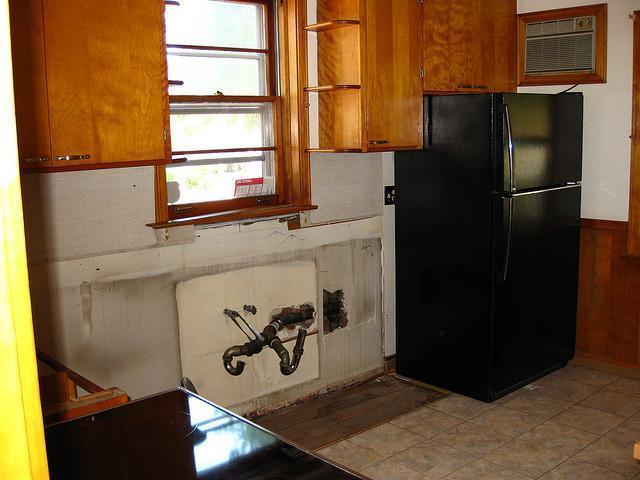How many appliances are there?
Give a very brief answer. 1. 